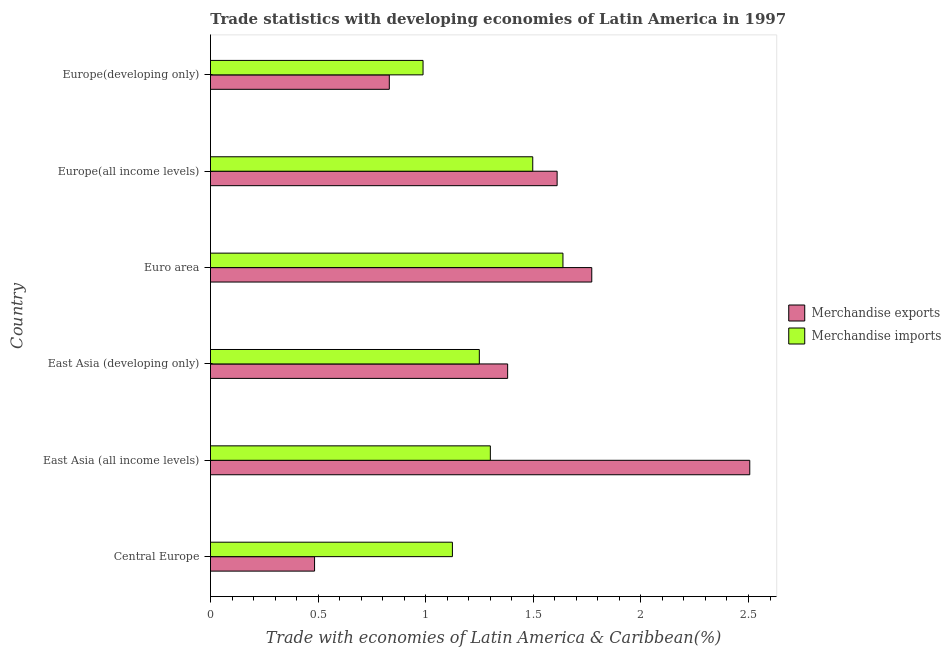How many different coloured bars are there?
Your answer should be compact. 2. How many bars are there on the 1st tick from the top?
Your answer should be very brief. 2. How many bars are there on the 3rd tick from the bottom?
Ensure brevity in your answer.  2. What is the label of the 4th group of bars from the top?
Your response must be concise. East Asia (developing only). In how many cases, is the number of bars for a given country not equal to the number of legend labels?
Provide a succinct answer. 0. What is the merchandise exports in East Asia (developing only)?
Give a very brief answer. 1.38. Across all countries, what is the maximum merchandise exports?
Offer a very short reply. 2.51. Across all countries, what is the minimum merchandise imports?
Keep it short and to the point. 0.99. In which country was the merchandise exports minimum?
Keep it short and to the point. Central Europe. What is the total merchandise exports in the graph?
Offer a very short reply. 8.58. What is the difference between the merchandise exports in Euro area and that in Europe(developing only)?
Provide a short and direct response. 0.94. What is the difference between the merchandise imports in Central Europe and the merchandise exports in East Asia (all income levels)?
Make the answer very short. -1.38. What is the average merchandise exports per country?
Offer a terse response. 1.43. What is the difference between the merchandise imports and merchandise exports in Euro area?
Keep it short and to the point. -0.13. In how many countries, is the merchandise exports greater than 1.9 %?
Your answer should be very brief. 1. Is the merchandise exports in East Asia (developing only) less than that in Europe(developing only)?
Offer a terse response. No. What is the difference between the highest and the second highest merchandise exports?
Offer a terse response. 0.73. What is the difference between the highest and the lowest merchandise exports?
Your response must be concise. 2.02. In how many countries, is the merchandise imports greater than the average merchandise imports taken over all countries?
Provide a short and direct response. 3. Is the sum of the merchandise exports in East Asia (all income levels) and Europe(all income levels) greater than the maximum merchandise imports across all countries?
Provide a short and direct response. Yes. What does the 1st bar from the bottom in Europe(all income levels) represents?
Keep it short and to the point. Merchandise exports. How many bars are there?
Your response must be concise. 12. How many countries are there in the graph?
Offer a terse response. 6. What is the difference between two consecutive major ticks on the X-axis?
Offer a terse response. 0.5. How many legend labels are there?
Give a very brief answer. 2. What is the title of the graph?
Provide a succinct answer. Trade statistics with developing economies of Latin America in 1997. What is the label or title of the X-axis?
Your response must be concise. Trade with economies of Latin America & Caribbean(%). What is the label or title of the Y-axis?
Provide a succinct answer. Country. What is the Trade with economies of Latin America & Caribbean(%) of Merchandise exports in Central Europe?
Your answer should be very brief. 0.48. What is the Trade with economies of Latin America & Caribbean(%) of Merchandise imports in Central Europe?
Give a very brief answer. 1.12. What is the Trade with economies of Latin America & Caribbean(%) in Merchandise exports in East Asia (all income levels)?
Make the answer very short. 2.51. What is the Trade with economies of Latin America & Caribbean(%) of Merchandise imports in East Asia (all income levels)?
Offer a terse response. 1.3. What is the Trade with economies of Latin America & Caribbean(%) of Merchandise exports in East Asia (developing only)?
Provide a succinct answer. 1.38. What is the Trade with economies of Latin America & Caribbean(%) of Merchandise imports in East Asia (developing only)?
Provide a succinct answer. 1.25. What is the Trade with economies of Latin America & Caribbean(%) of Merchandise exports in Euro area?
Make the answer very short. 1.77. What is the Trade with economies of Latin America & Caribbean(%) in Merchandise imports in Euro area?
Give a very brief answer. 1.64. What is the Trade with economies of Latin America & Caribbean(%) of Merchandise exports in Europe(all income levels)?
Give a very brief answer. 1.61. What is the Trade with economies of Latin America & Caribbean(%) of Merchandise imports in Europe(all income levels)?
Your response must be concise. 1.5. What is the Trade with economies of Latin America & Caribbean(%) in Merchandise exports in Europe(developing only)?
Keep it short and to the point. 0.83. What is the Trade with economies of Latin America & Caribbean(%) in Merchandise imports in Europe(developing only)?
Your answer should be compact. 0.99. Across all countries, what is the maximum Trade with economies of Latin America & Caribbean(%) of Merchandise exports?
Your response must be concise. 2.51. Across all countries, what is the maximum Trade with economies of Latin America & Caribbean(%) in Merchandise imports?
Offer a terse response. 1.64. Across all countries, what is the minimum Trade with economies of Latin America & Caribbean(%) in Merchandise exports?
Keep it short and to the point. 0.48. Across all countries, what is the minimum Trade with economies of Latin America & Caribbean(%) in Merchandise imports?
Ensure brevity in your answer.  0.99. What is the total Trade with economies of Latin America & Caribbean(%) of Merchandise exports in the graph?
Offer a terse response. 8.58. What is the total Trade with economies of Latin America & Caribbean(%) in Merchandise imports in the graph?
Provide a succinct answer. 7.8. What is the difference between the Trade with economies of Latin America & Caribbean(%) in Merchandise exports in Central Europe and that in East Asia (all income levels)?
Give a very brief answer. -2.02. What is the difference between the Trade with economies of Latin America & Caribbean(%) of Merchandise imports in Central Europe and that in East Asia (all income levels)?
Your response must be concise. -0.18. What is the difference between the Trade with economies of Latin America & Caribbean(%) of Merchandise exports in Central Europe and that in East Asia (developing only)?
Your answer should be very brief. -0.9. What is the difference between the Trade with economies of Latin America & Caribbean(%) in Merchandise imports in Central Europe and that in East Asia (developing only)?
Keep it short and to the point. -0.13. What is the difference between the Trade with economies of Latin America & Caribbean(%) of Merchandise exports in Central Europe and that in Euro area?
Offer a very short reply. -1.29. What is the difference between the Trade with economies of Latin America & Caribbean(%) of Merchandise imports in Central Europe and that in Euro area?
Make the answer very short. -0.51. What is the difference between the Trade with economies of Latin America & Caribbean(%) of Merchandise exports in Central Europe and that in Europe(all income levels)?
Offer a terse response. -1.13. What is the difference between the Trade with economies of Latin America & Caribbean(%) of Merchandise imports in Central Europe and that in Europe(all income levels)?
Provide a short and direct response. -0.37. What is the difference between the Trade with economies of Latin America & Caribbean(%) of Merchandise exports in Central Europe and that in Europe(developing only)?
Give a very brief answer. -0.35. What is the difference between the Trade with economies of Latin America & Caribbean(%) in Merchandise imports in Central Europe and that in Europe(developing only)?
Your answer should be very brief. 0.14. What is the difference between the Trade with economies of Latin America & Caribbean(%) in Merchandise exports in East Asia (all income levels) and that in East Asia (developing only)?
Give a very brief answer. 1.13. What is the difference between the Trade with economies of Latin America & Caribbean(%) of Merchandise imports in East Asia (all income levels) and that in East Asia (developing only)?
Your answer should be very brief. 0.05. What is the difference between the Trade with economies of Latin America & Caribbean(%) of Merchandise exports in East Asia (all income levels) and that in Euro area?
Provide a short and direct response. 0.73. What is the difference between the Trade with economies of Latin America & Caribbean(%) of Merchandise imports in East Asia (all income levels) and that in Euro area?
Ensure brevity in your answer.  -0.34. What is the difference between the Trade with economies of Latin America & Caribbean(%) of Merchandise exports in East Asia (all income levels) and that in Europe(all income levels)?
Your answer should be very brief. 0.9. What is the difference between the Trade with economies of Latin America & Caribbean(%) of Merchandise imports in East Asia (all income levels) and that in Europe(all income levels)?
Give a very brief answer. -0.2. What is the difference between the Trade with economies of Latin America & Caribbean(%) of Merchandise exports in East Asia (all income levels) and that in Europe(developing only)?
Provide a short and direct response. 1.67. What is the difference between the Trade with economies of Latin America & Caribbean(%) of Merchandise imports in East Asia (all income levels) and that in Europe(developing only)?
Your answer should be compact. 0.31. What is the difference between the Trade with economies of Latin America & Caribbean(%) in Merchandise exports in East Asia (developing only) and that in Euro area?
Ensure brevity in your answer.  -0.39. What is the difference between the Trade with economies of Latin America & Caribbean(%) of Merchandise imports in East Asia (developing only) and that in Euro area?
Make the answer very short. -0.39. What is the difference between the Trade with economies of Latin America & Caribbean(%) in Merchandise exports in East Asia (developing only) and that in Europe(all income levels)?
Provide a succinct answer. -0.23. What is the difference between the Trade with economies of Latin America & Caribbean(%) of Merchandise imports in East Asia (developing only) and that in Europe(all income levels)?
Make the answer very short. -0.25. What is the difference between the Trade with economies of Latin America & Caribbean(%) of Merchandise exports in East Asia (developing only) and that in Europe(developing only)?
Offer a very short reply. 0.55. What is the difference between the Trade with economies of Latin America & Caribbean(%) in Merchandise imports in East Asia (developing only) and that in Europe(developing only)?
Make the answer very short. 0.26. What is the difference between the Trade with economies of Latin America & Caribbean(%) of Merchandise exports in Euro area and that in Europe(all income levels)?
Give a very brief answer. 0.16. What is the difference between the Trade with economies of Latin America & Caribbean(%) in Merchandise imports in Euro area and that in Europe(all income levels)?
Ensure brevity in your answer.  0.14. What is the difference between the Trade with economies of Latin America & Caribbean(%) of Merchandise exports in Euro area and that in Europe(developing only)?
Your answer should be compact. 0.94. What is the difference between the Trade with economies of Latin America & Caribbean(%) in Merchandise imports in Euro area and that in Europe(developing only)?
Give a very brief answer. 0.65. What is the difference between the Trade with economies of Latin America & Caribbean(%) of Merchandise exports in Europe(all income levels) and that in Europe(developing only)?
Make the answer very short. 0.78. What is the difference between the Trade with economies of Latin America & Caribbean(%) in Merchandise imports in Europe(all income levels) and that in Europe(developing only)?
Give a very brief answer. 0.51. What is the difference between the Trade with economies of Latin America & Caribbean(%) of Merchandise exports in Central Europe and the Trade with economies of Latin America & Caribbean(%) of Merchandise imports in East Asia (all income levels)?
Offer a very short reply. -0.82. What is the difference between the Trade with economies of Latin America & Caribbean(%) of Merchandise exports in Central Europe and the Trade with economies of Latin America & Caribbean(%) of Merchandise imports in East Asia (developing only)?
Provide a succinct answer. -0.77. What is the difference between the Trade with economies of Latin America & Caribbean(%) of Merchandise exports in Central Europe and the Trade with economies of Latin America & Caribbean(%) of Merchandise imports in Euro area?
Ensure brevity in your answer.  -1.15. What is the difference between the Trade with economies of Latin America & Caribbean(%) in Merchandise exports in Central Europe and the Trade with economies of Latin America & Caribbean(%) in Merchandise imports in Europe(all income levels)?
Keep it short and to the point. -1.01. What is the difference between the Trade with economies of Latin America & Caribbean(%) in Merchandise exports in Central Europe and the Trade with economies of Latin America & Caribbean(%) in Merchandise imports in Europe(developing only)?
Keep it short and to the point. -0.5. What is the difference between the Trade with economies of Latin America & Caribbean(%) of Merchandise exports in East Asia (all income levels) and the Trade with economies of Latin America & Caribbean(%) of Merchandise imports in East Asia (developing only)?
Offer a terse response. 1.26. What is the difference between the Trade with economies of Latin America & Caribbean(%) in Merchandise exports in East Asia (all income levels) and the Trade with economies of Latin America & Caribbean(%) in Merchandise imports in Euro area?
Your answer should be compact. 0.87. What is the difference between the Trade with economies of Latin America & Caribbean(%) of Merchandise exports in East Asia (all income levels) and the Trade with economies of Latin America & Caribbean(%) of Merchandise imports in Europe(all income levels)?
Offer a terse response. 1.01. What is the difference between the Trade with economies of Latin America & Caribbean(%) of Merchandise exports in East Asia (all income levels) and the Trade with economies of Latin America & Caribbean(%) of Merchandise imports in Europe(developing only)?
Keep it short and to the point. 1.52. What is the difference between the Trade with economies of Latin America & Caribbean(%) of Merchandise exports in East Asia (developing only) and the Trade with economies of Latin America & Caribbean(%) of Merchandise imports in Euro area?
Ensure brevity in your answer.  -0.26. What is the difference between the Trade with economies of Latin America & Caribbean(%) of Merchandise exports in East Asia (developing only) and the Trade with economies of Latin America & Caribbean(%) of Merchandise imports in Europe(all income levels)?
Make the answer very short. -0.12. What is the difference between the Trade with economies of Latin America & Caribbean(%) in Merchandise exports in East Asia (developing only) and the Trade with economies of Latin America & Caribbean(%) in Merchandise imports in Europe(developing only)?
Your answer should be compact. 0.39. What is the difference between the Trade with economies of Latin America & Caribbean(%) of Merchandise exports in Euro area and the Trade with economies of Latin America & Caribbean(%) of Merchandise imports in Europe(all income levels)?
Offer a very short reply. 0.27. What is the difference between the Trade with economies of Latin America & Caribbean(%) of Merchandise exports in Euro area and the Trade with economies of Latin America & Caribbean(%) of Merchandise imports in Europe(developing only)?
Make the answer very short. 0.78. What is the difference between the Trade with economies of Latin America & Caribbean(%) in Merchandise exports in Europe(all income levels) and the Trade with economies of Latin America & Caribbean(%) in Merchandise imports in Europe(developing only)?
Ensure brevity in your answer.  0.62. What is the average Trade with economies of Latin America & Caribbean(%) of Merchandise exports per country?
Make the answer very short. 1.43. What is the average Trade with economies of Latin America & Caribbean(%) of Merchandise imports per country?
Your answer should be very brief. 1.3. What is the difference between the Trade with economies of Latin America & Caribbean(%) of Merchandise exports and Trade with economies of Latin America & Caribbean(%) of Merchandise imports in Central Europe?
Offer a very short reply. -0.64. What is the difference between the Trade with economies of Latin America & Caribbean(%) of Merchandise exports and Trade with economies of Latin America & Caribbean(%) of Merchandise imports in East Asia (all income levels)?
Your answer should be very brief. 1.21. What is the difference between the Trade with economies of Latin America & Caribbean(%) of Merchandise exports and Trade with economies of Latin America & Caribbean(%) of Merchandise imports in East Asia (developing only)?
Your answer should be very brief. 0.13. What is the difference between the Trade with economies of Latin America & Caribbean(%) in Merchandise exports and Trade with economies of Latin America & Caribbean(%) in Merchandise imports in Euro area?
Your answer should be compact. 0.13. What is the difference between the Trade with economies of Latin America & Caribbean(%) of Merchandise exports and Trade with economies of Latin America & Caribbean(%) of Merchandise imports in Europe(all income levels)?
Make the answer very short. 0.11. What is the difference between the Trade with economies of Latin America & Caribbean(%) of Merchandise exports and Trade with economies of Latin America & Caribbean(%) of Merchandise imports in Europe(developing only)?
Give a very brief answer. -0.16. What is the ratio of the Trade with economies of Latin America & Caribbean(%) of Merchandise exports in Central Europe to that in East Asia (all income levels)?
Keep it short and to the point. 0.19. What is the ratio of the Trade with economies of Latin America & Caribbean(%) in Merchandise imports in Central Europe to that in East Asia (all income levels)?
Ensure brevity in your answer.  0.86. What is the ratio of the Trade with economies of Latin America & Caribbean(%) of Merchandise exports in Central Europe to that in East Asia (developing only)?
Offer a terse response. 0.35. What is the ratio of the Trade with economies of Latin America & Caribbean(%) in Merchandise imports in Central Europe to that in East Asia (developing only)?
Provide a succinct answer. 0.9. What is the ratio of the Trade with economies of Latin America & Caribbean(%) of Merchandise exports in Central Europe to that in Euro area?
Your answer should be compact. 0.27. What is the ratio of the Trade with economies of Latin America & Caribbean(%) in Merchandise imports in Central Europe to that in Euro area?
Give a very brief answer. 0.69. What is the ratio of the Trade with economies of Latin America & Caribbean(%) of Merchandise exports in Central Europe to that in Europe(all income levels)?
Offer a very short reply. 0.3. What is the ratio of the Trade with economies of Latin America & Caribbean(%) in Merchandise imports in Central Europe to that in Europe(all income levels)?
Provide a succinct answer. 0.75. What is the ratio of the Trade with economies of Latin America & Caribbean(%) in Merchandise exports in Central Europe to that in Europe(developing only)?
Make the answer very short. 0.58. What is the ratio of the Trade with economies of Latin America & Caribbean(%) of Merchandise imports in Central Europe to that in Europe(developing only)?
Provide a short and direct response. 1.14. What is the ratio of the Trade with economies of Latin America & Caribbean(%) of Merchandise exports in East Asia (all income levels) to that in East Asia (developing only)?
Offer a very short reply. 1.81. What is the ratio of the Trade with economies of Latin America & Caribbean(%) of Merchandise imports in East Asia (all income levels) to that in East Asia (developing only)?
Provide a succinct answer. 1.04. What is the ratio of the Trade with economies of Latin America & Caribbean(%) of Merchandise exports in East Asia (all income levels) to that in Euro area?
Ensure brevity in your answer.  1.41. What is the ratio of the Trade with economies of Latin America & Caribbean(%) in Merchandise imports in East Asia (all income levels) to that in Euro area?
Give a very brief answer. 0.79. What is the ratio of the Trade with economies of Latin America & Caribbean(%) in Merchandise exports in East Asia (all income levels) to that in Europe(all income levels)?
Offer a terse response. 1.56. What is the ratio of the Trade with economies of Latin America & Caribbean(%) in Merchandise imports in East Asia (all income levels) to that in Europe(all income levels)?
Offer a terse response. 0.87. What is the ratio of the Trade with economies of Latin America & Caribbean(%) in Merchandise exports in East Asia (all income levels) to that in Europe(developing only)?
Provide a succinct answer. 3.02. What is the ratio of the Trade with economies of Latin America & Caribbean(%) in Merchandise imports in East Asia (all income levels) to that in Europe(developing only)?
Your answer should be compact. 1.32. What is the ratio of the Trade with economies of Latin America & Caribbean(%) of Merchandise exports in East Asia (developing only) to that in Euro area?
Offer a very short reply. 0.78. What is the ratio of the Trade with economies of Latin America & Caribbean(%) of Merchandise imports in East Asia (developing only) to that in Euro area?
Ensure brevity in your answer.  0.76. What is the ratio of the Trade with economies of Latin America & Caribbean(%) in Merchandise exports in East Asia (developing only) to that in Europe(all income levels)?
Your answer should be compact. 0.86. What is the ratio of the Trade with economies of Latin America & Caribbean(%) in Merchandise imports in East Asia (developing only) to that in Europe(all income levels)?
Make the answer very short. 0.83. What is the ratio of the Trade with economies of Latin America & Caribbean(%) of Merchandise exports in East Asia (developing only) to that in Europe(developing only)?
Give a very brief answer. 1.66. What is the ratio of the Trade with economies of Latin America & Caribbean(%) in Merchandise imports in East Asia (developing only) to that in Europe(developing only)?
Your answer should be very brief. 1.26. What is the ratio of the Trade with economies of Latin America & Caribbean(%) in Merchandise exports in Euro area to that in Europe(all income levels)?
Ensure brevity in your answer.  1.1. What is the ratio of the Trade with economies of Latin America & Caribbean(%) in Merchandise imports in Euro area to that in Europe(all income levels)?
Provide a succinct answer. 1.09. What is the ratio of the Trade with economies of Latin America & Caribbean(%) of Merchandise exports in Euro area to that in Europe(developing only)?
Offer a terse response. 2.13. What is the ratio of the Trade with economies of Latin America & Caribbean(%) of Merchandise imports in Euro area to that in Europe(developing only)?
Provide a succinct answer. 1.66. What is the ratio of the Trade with economies of Latin America & Caribbean(%) in Merchandise exports in Europe(all income levels) to that in Europe(developing only)?
Offer a very short reply. 1.94. What is the ratio of the Trade with economies of Latin America & Caribbean(%) in Merchandise imports in Europe(all income levels) to that in Europe(developing only)?
Provide a succinct answer. 1.52. What is the difference between the highest and the second highest Trade with economies of Latin America & Caribbean(%) of Merchandise exports?
Keep it short and to the point. 0.73. What is the difference between the highest and the second highest Trade with economies of Latin America & Caribbean(%) of Merchandise imports?
Your response must be concise. 0.14. What is the difference between the highest and the lowest Trade with economies of Latin America & Caribbean(%) in Merchandise exports?
Keep it short and to the point. 2.02. What is the difference between the highest and the lowest Trade with economies of Latin America & Caribbean(%) of Merchandise imports?
Ensure brevity in your answer.  0.65. 